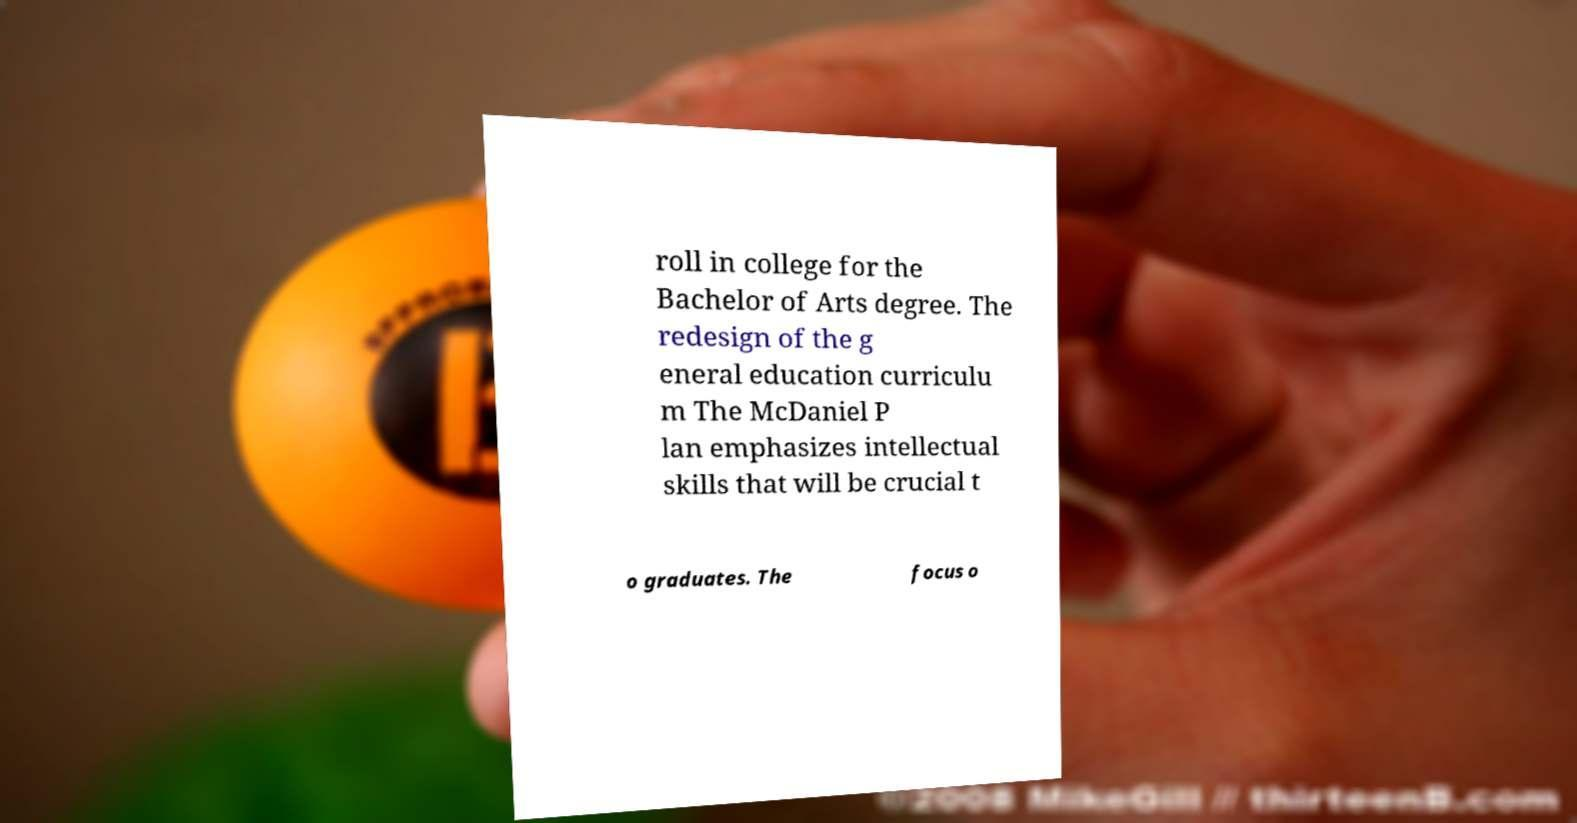For documentation purposes, I need the text within this image transcribed. Could you provide that? roll in college for the Bachelor of Arts degree. The redesign of the g eneral education curriculu m The McDaniel P lan emphasizes intellectual skills that will be crucial t o graduates. The focus o 